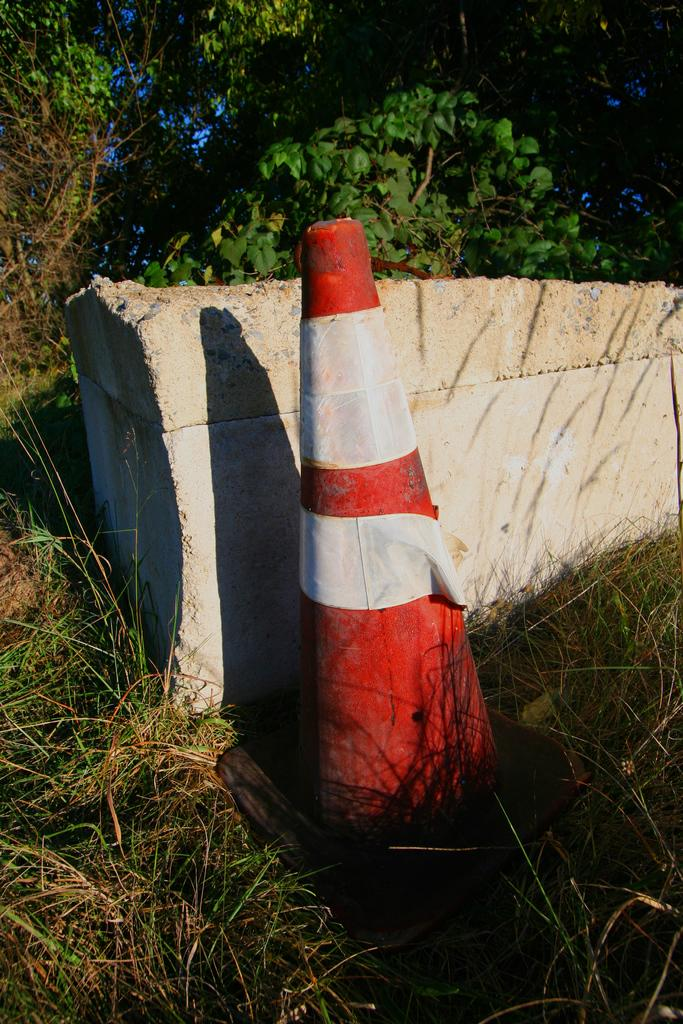What type of vegetation can be seen in the image? There is grass in the image. What other objects are present in the image? There is a stone and a traffic cone in the image. What can be seen in the background of the image? There are trees in the background of the image. What song is being sung by the stone in the image? There is no indication in the image that the stone is singing a song, as stones do not have the ability to sing. 